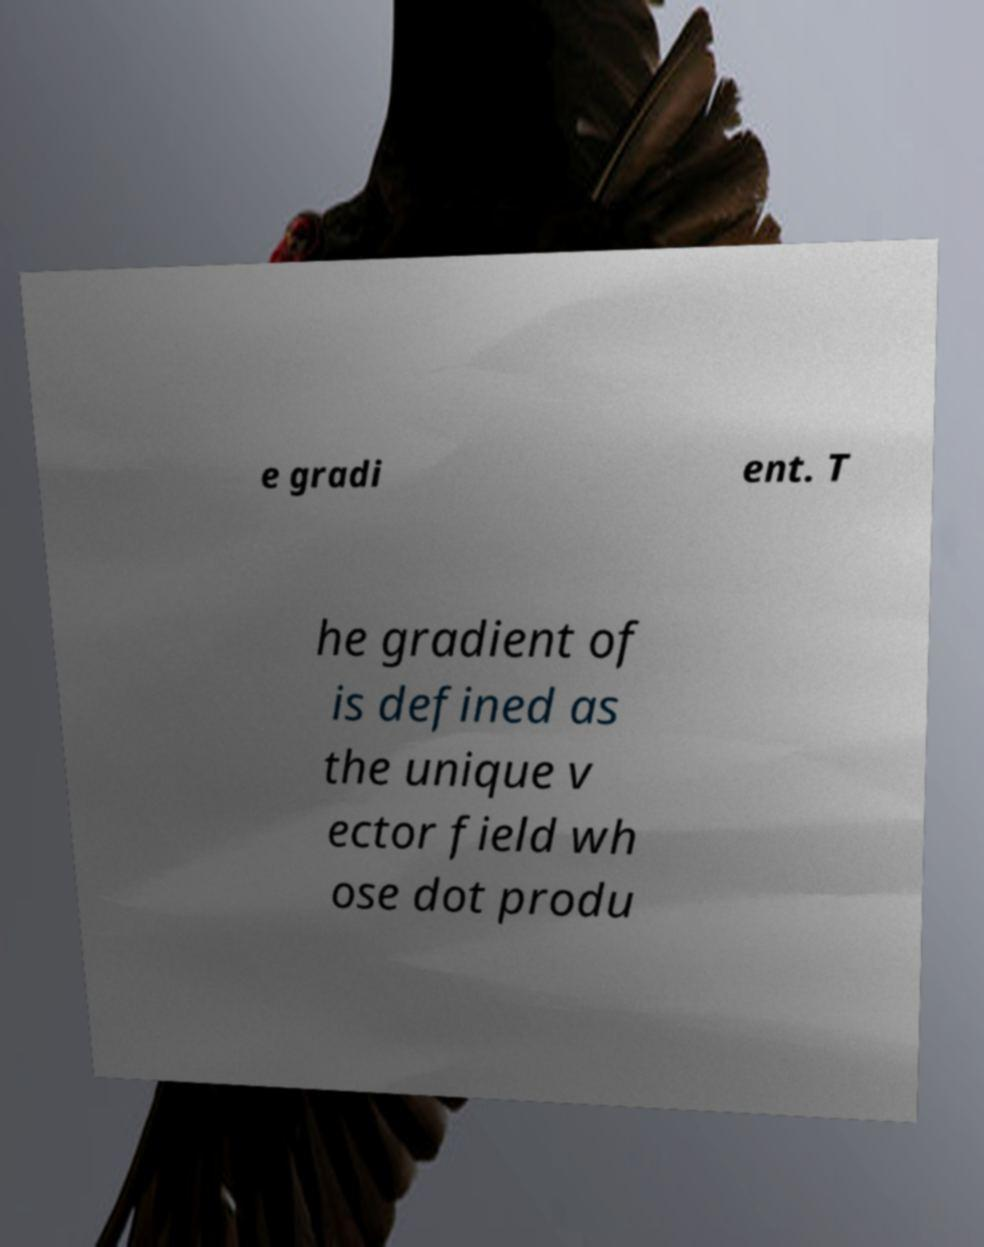What messages or text are displayed in this image? I need them in a readable, typed format. e gradi ent. T he gradient of is defined as the unique v ector field wh ose dot produ 